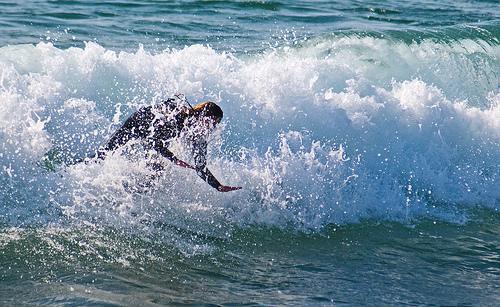How many people are there?
Give a very brief answer. 1. 